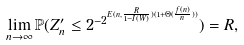<formula> <loc_0><loc_0><loc_500><loc_500>\lim _ { n \to \infty } \mathbb { P } ( Z ^ { \prime } _ { n } \leq 2 ^ { - 2 ^ { E ( n , \frac { R } { 1 - I ( W ) } ) ( 1 + \Theta ( \frac { f ( n ) } { n } ) ) } } ) = R ,</formula> 